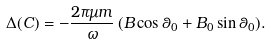Convert formula to latex. <formula><loc_0><loc_0><loc_500><loc_500>\Delta ( C ) = - \frac { 2 \pi \mu m } { \omega } \, ( B \cos \theta _ { 0 } + B _ { 0 } \sin \theta _ { 0 } ) .</formula> 